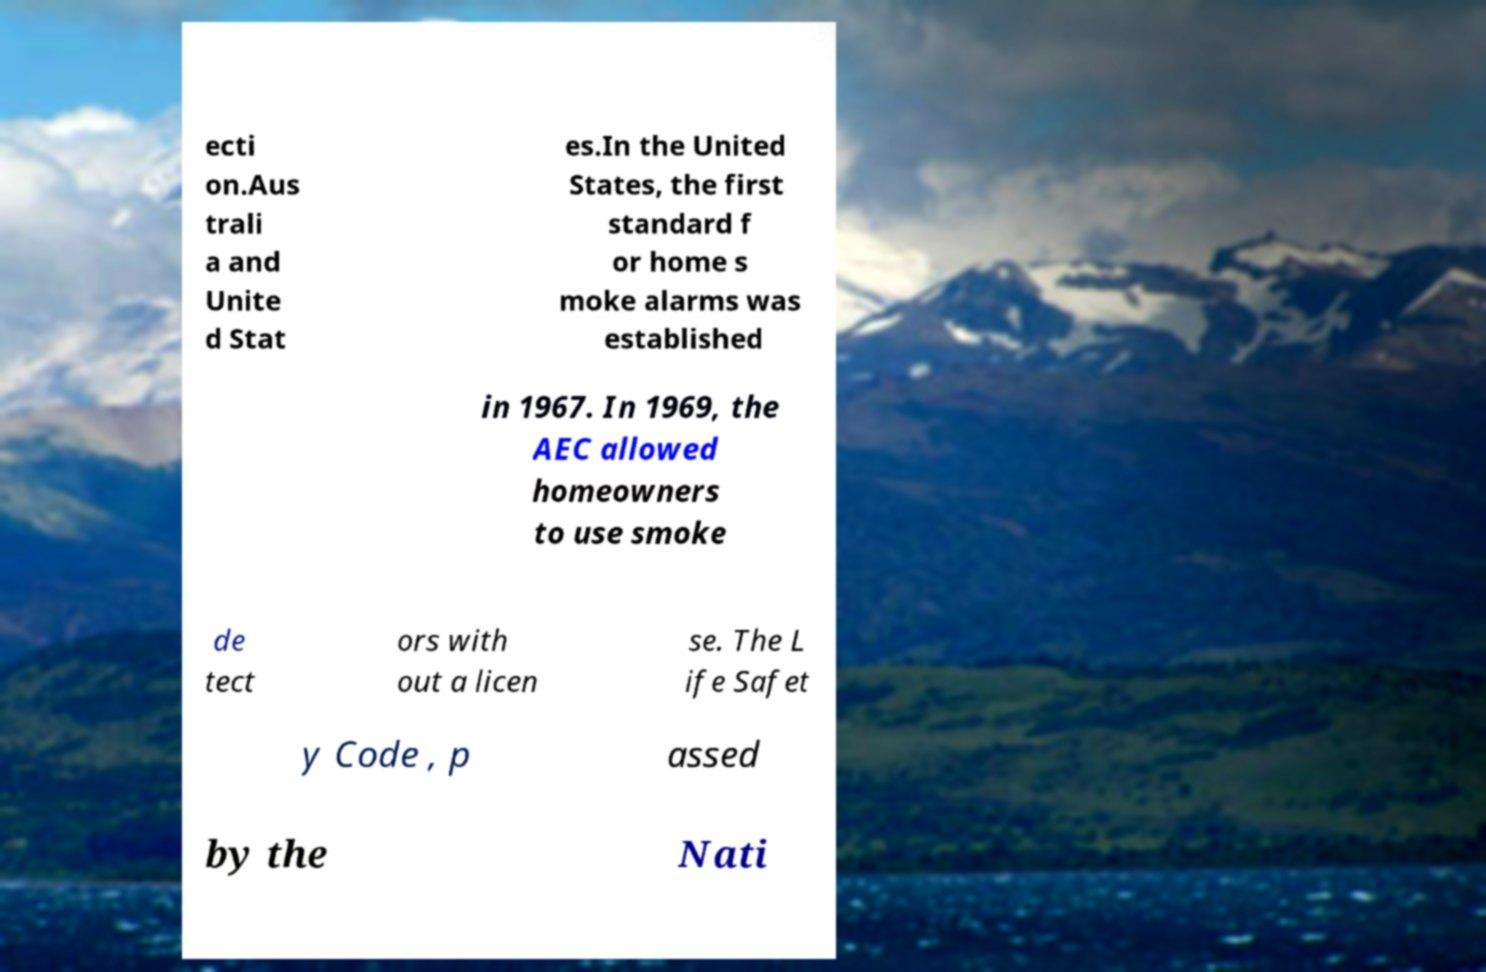Could you extract and type out the text from this image? ecti on.Aus trali a and Unite d Stat es.In the United States, the first standard f or home s moke alarms was established in 1967. In 1969, the AEC allowed homeowners to use smoke de tect ors with out a licen se. The L ife Safet y Code , p assed by the Nati 